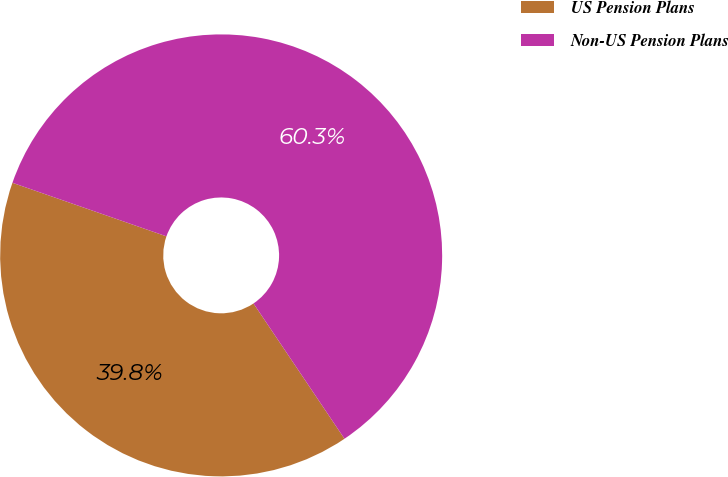Convert chart. <chart><loc_0><loc_0><loc_500><loc_500><pie_chart><fcel>US Pension Plans<fcel>Non-US Pension Plans<nl><fcel>39.75%<fcel>60.25%<nl></chart> 